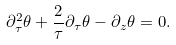Convert formula to latex. <formula><loc_0><loc_0><loc_500><loc_500>\partial _ { \tau } ^ { 2 } \theta + \frac { 2 } { \tau } \partial _ { \tau } \theta - \partial _ { z } \theta = 0 .</formula> 